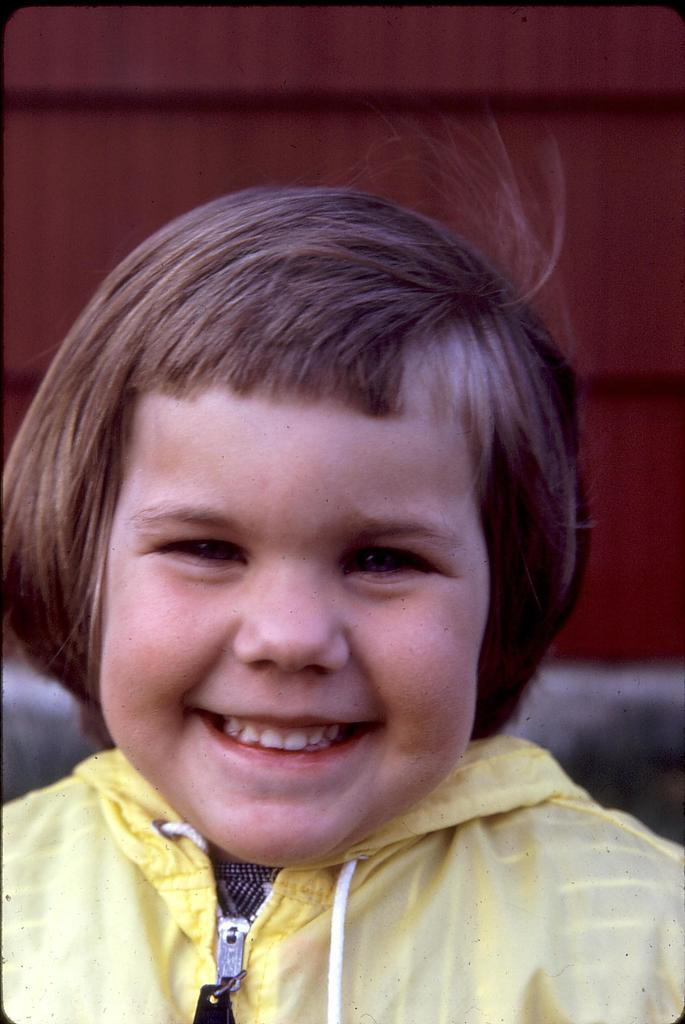Who or what is the main subject of the image? There is a person in the image. What is the person wearing in the image? The person is wearing a yellow jacket. What is the person's facial expression in the image? The person is smiling. What color is the background of the image? The background of the image is maroon. How was the image created or modified? The image is an edited picture. What type of feather can be seen in the person's hair in the image? There is no feather visible in the person's hair in the image. What is the person holding in their hand in the image? The provided facts do not mention any object the person is holding in their hand. 